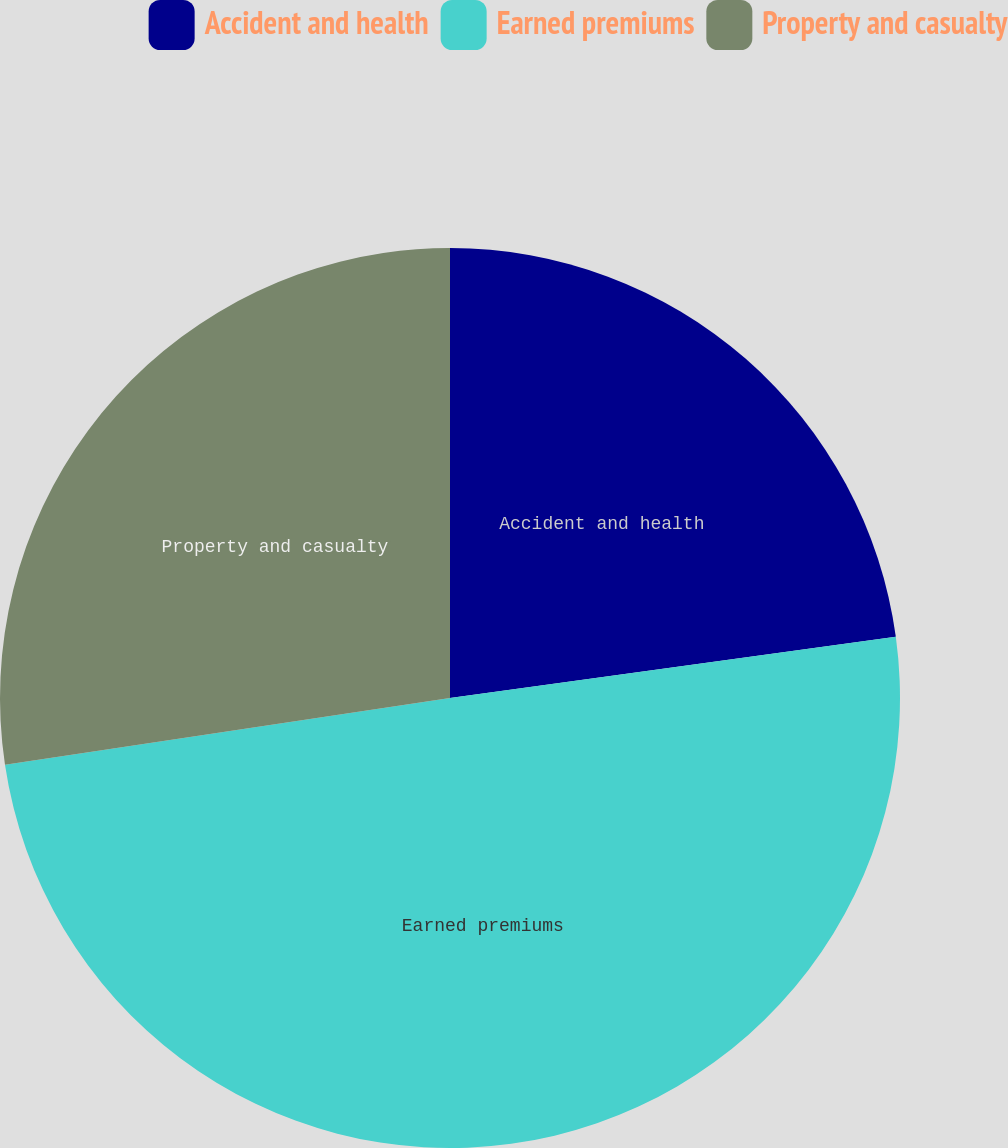Convert chart. <chart><loc_0><loc_0><loc_500><loc_500><pie_chart><fcel>Accident and health<fcel>Earned premiums<fcel>Property and casualty<nl><fcel>22.83%<fcel>49.8%<fcel>27.37%<nl></chart> 